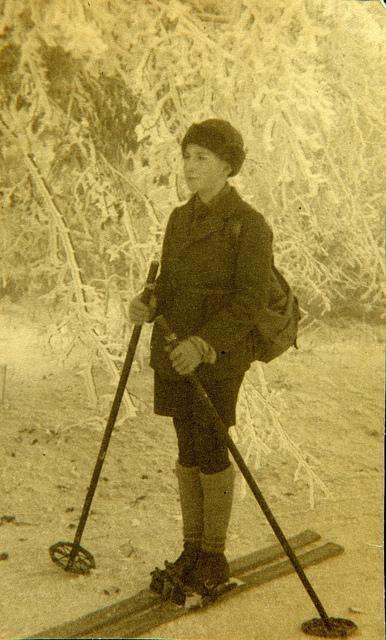How many people are in the photo?
Give a very brief answer. 1. 